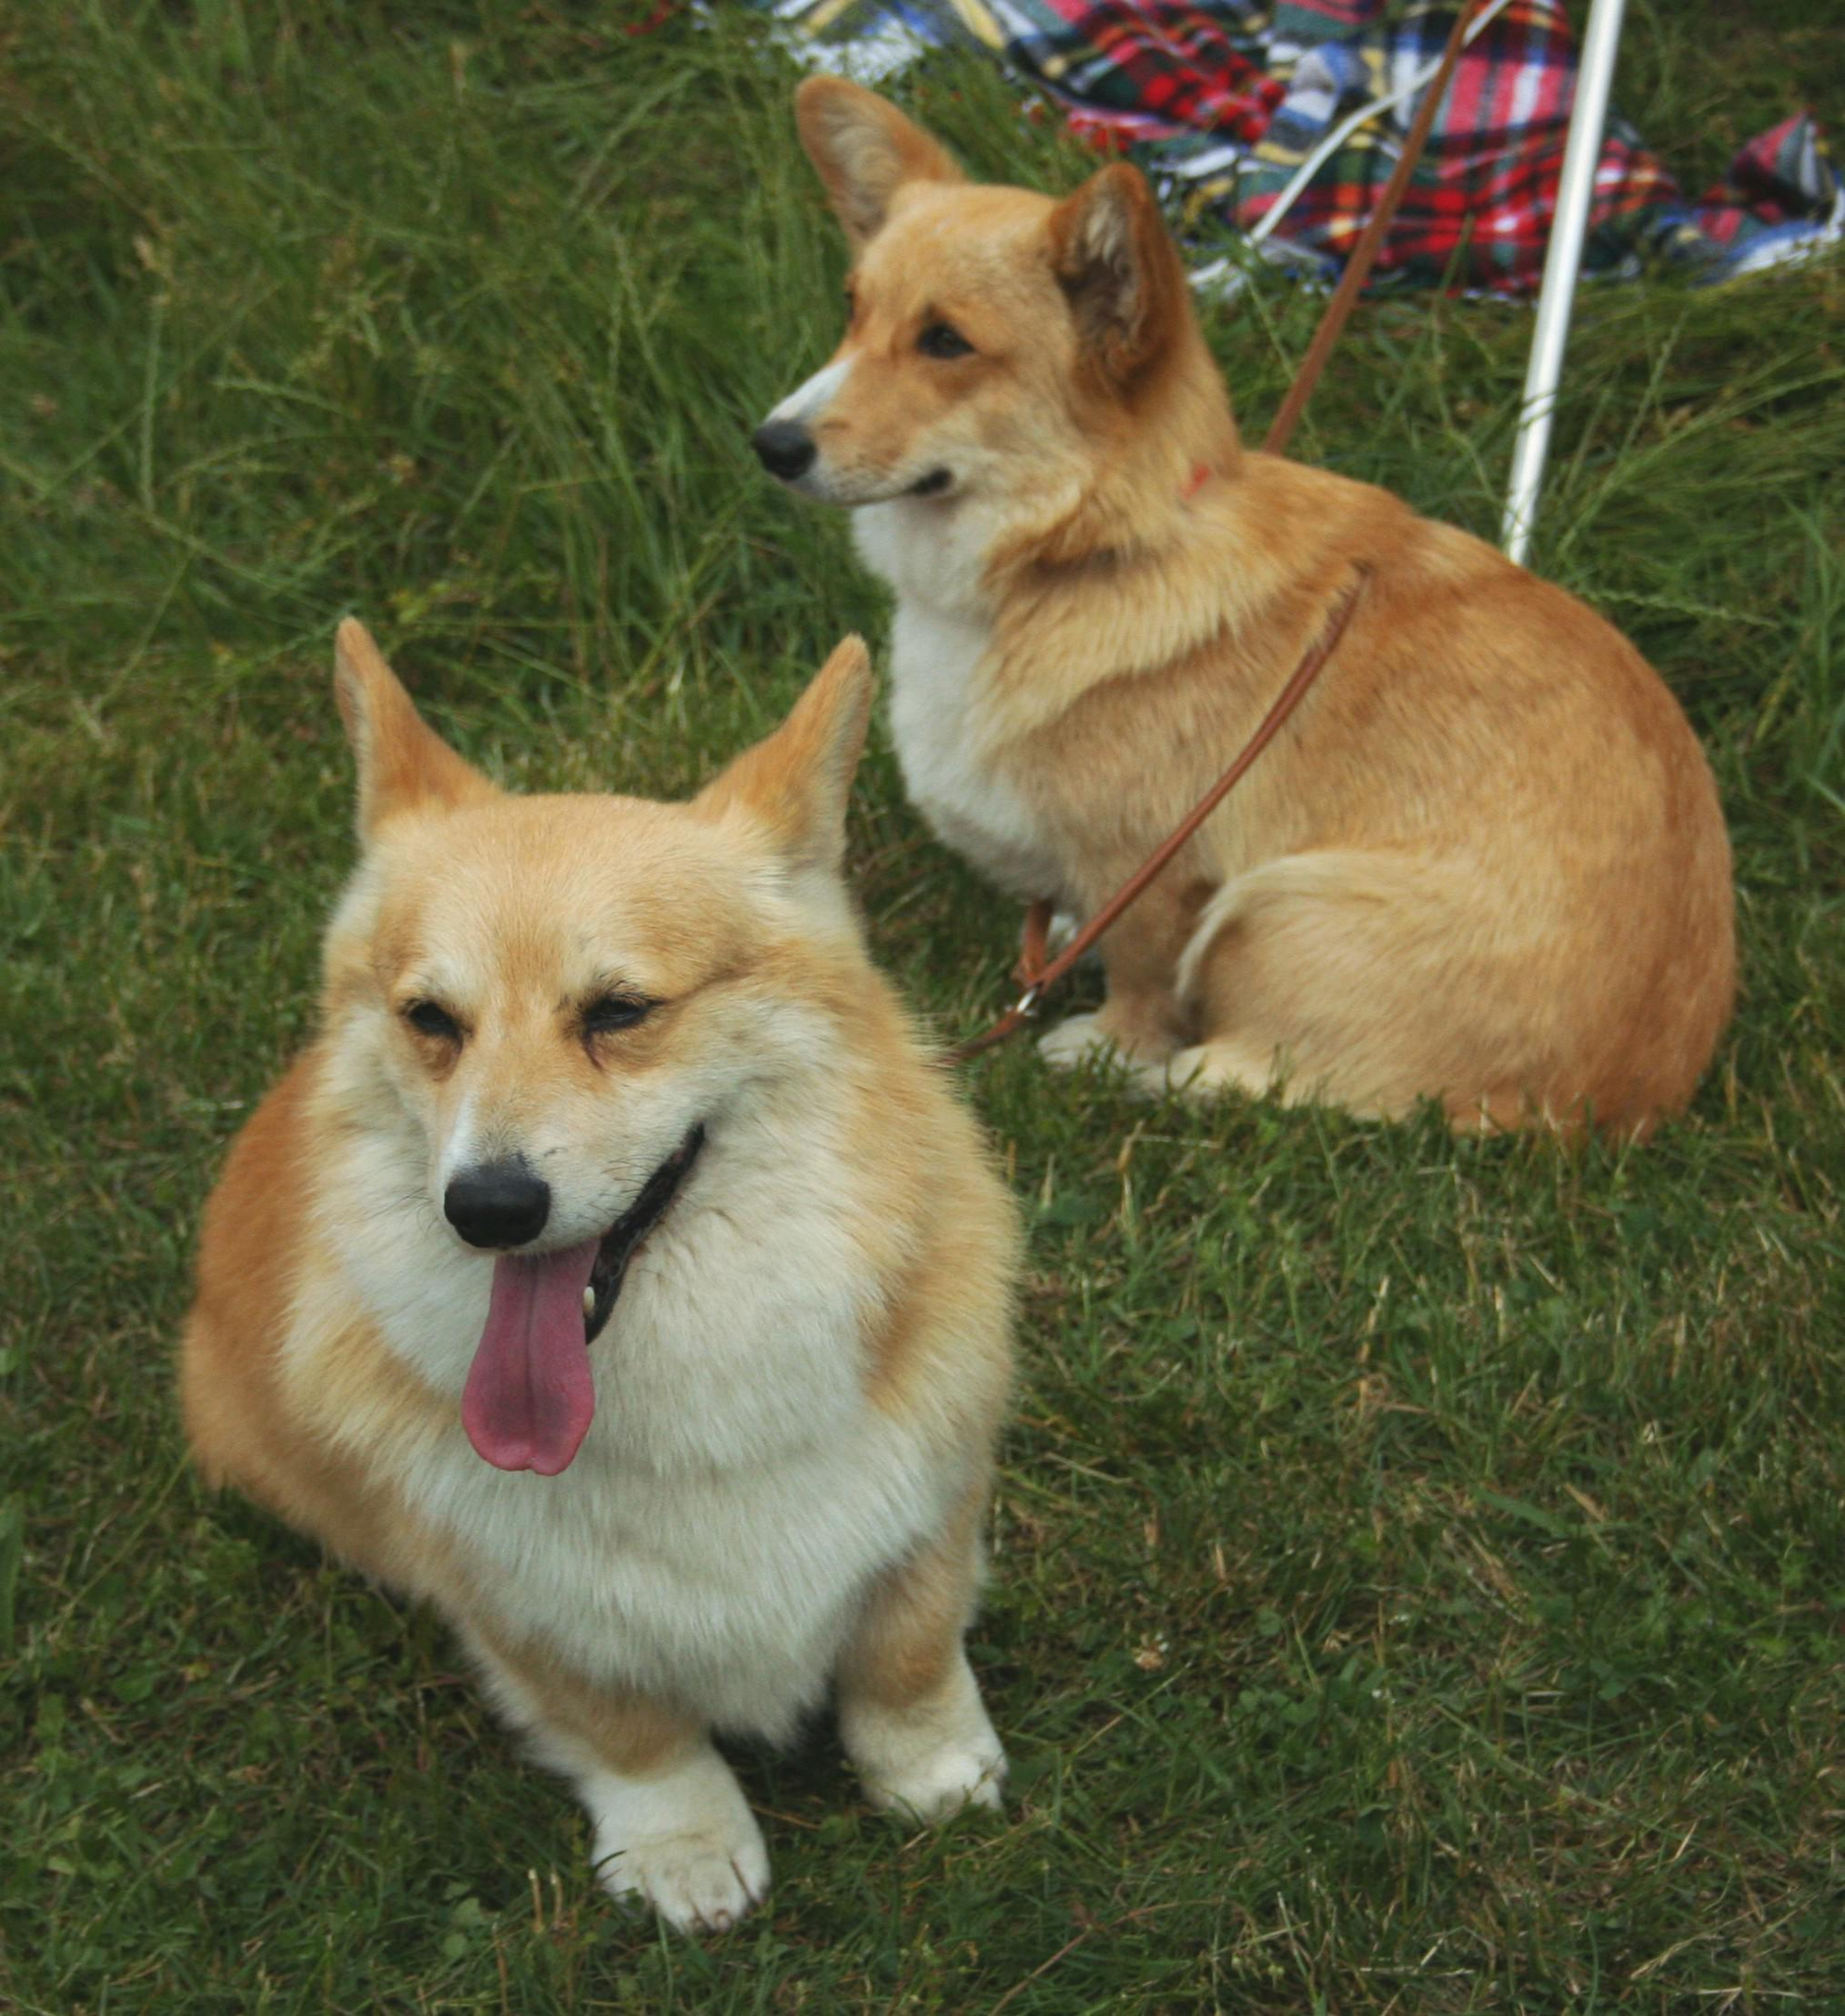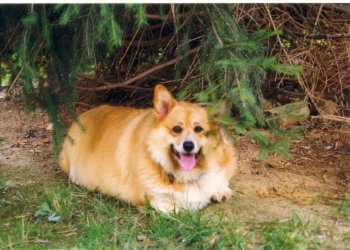The first image is the image on the left, the second image is the image on the right. For the images shown, is this caption "There are at least three dogs." true? Answer yes or no. Yes. The first image is the image on the left, the second image is the image on the right. For the images shown, is this caption "One image contains at least twice as many corgi dogs as the other image." true? Answer yes or no. Yes. 